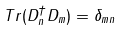Convert formula to latex. <formula><loc_0><loc_0><loc_500><loc_500>T r ( D _ { n } ^ { \dag } D _ { m } ) = \delta _ { m n }</formula> 